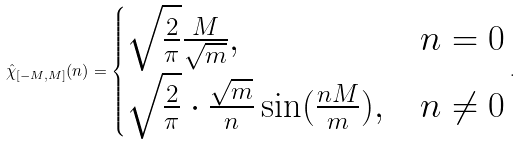<formula> <loc_0><loc_0><loc_500><loc_500>\hat { \chi } _ { [ - M , M ] } ( n ) = \begin{cases} \sqrt { \frac { 2 } { \pi } } \frac { M } { \sqrt { m } } , & n = 0 \\ \sqrt { \frac { 2 } { \pi } } \cdot \frac { \sqrt { m } } { n } \sin ( \frac { n M } { m } ) , & n \ne 0 \end{cases} .</formula> 